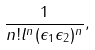Convert formula to latex. <formula><loc_0><loc_0><loc_500><loc_500>\frac { 1 } { n ! l ^ { n } ( \epsilon _ { 1 } \epsilon _ { 2 } ) ^ { n } } ,</formula> 